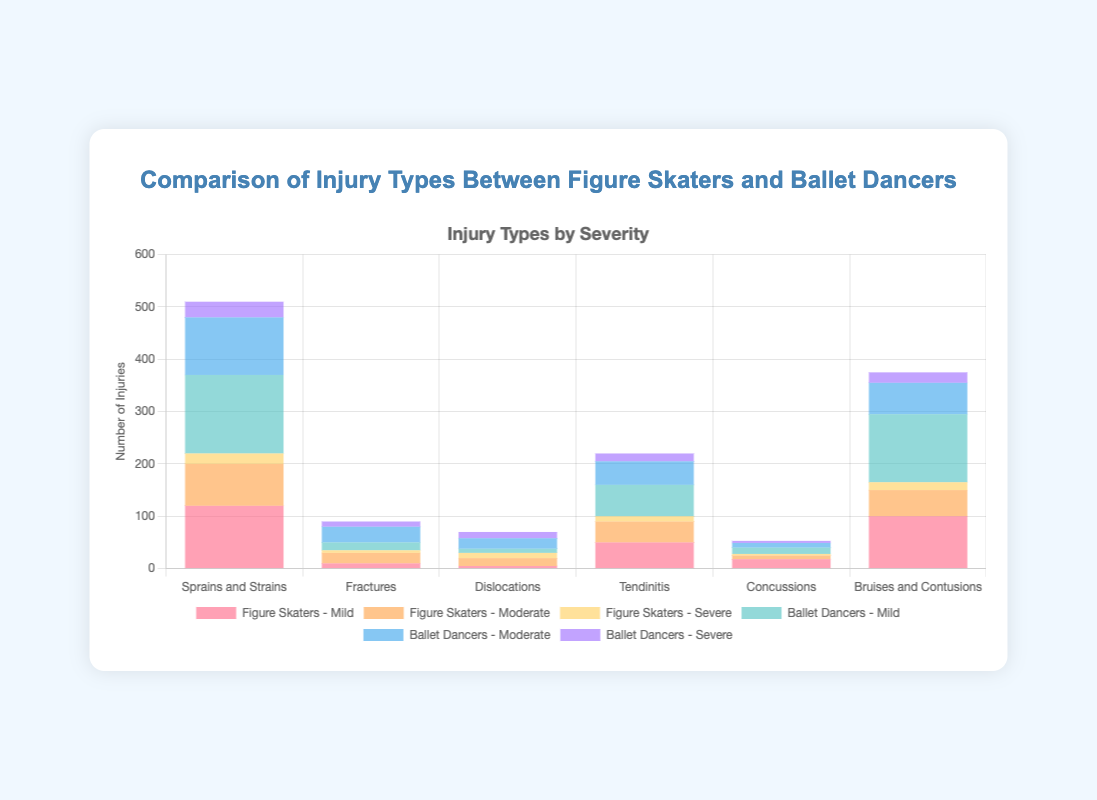Which group has the highest number of severe injuries for Sprains and Strains? To find the group with the highest number of severe injuries for Sprains and Strains, compare the severe counts between figure skaters and ballet dancers. Figure skaters have 20 severe injuries, while ballet dancers have 30. Therefore, ballet dancers have the highest number.
Answer: Ballet dancers In the category of Fractures, what is the total number of injuries that figure skaters experience? Add up the mild, moderate, and severe injuries for figure skaters in the Fractures category. The numbers are 10 (mild) + 20 (moderate) + 5 (severe), totaling 35 injuries.
Answer: 35 Which injury type has the highest number of moderate injuries for ballet dancers? To find the injury type with the highest number of moderate injuries for ballet dancers, compare moderate injury numbers for each type. The values are 110 (Sprains and Strains), 30 (Fractures), 20 (Dislocations), 45 (Tendinitis), 9 (Concussions), and 60 (Bruises and Contusions). The highest number is 110 for Sprains and Strains.
Answer: Sprains and Strains What is the ratio of mild to severe injuries for figure skaters in the Tendinitis category? Calculate the ratio by dividing the number of mild injuries by the number of severe injuries for figure skaters in the Tendinitis category. The values are 50 (mild) and 10 (severe), so the ratio is 50/10 = 5.
Answer: 5 How many more moderate injuries do figure skaters have compared to ballet dancers in the Fractures category? Subtract the number of moderate Fractures for ballet dancers from the number for figure skaters. Figure skaters have 20, and ballet dancers have 30, so the difference is 30 - 20 = 10.
Answer: 10 What color represents the severe injuries for ballet dancers? By observing the legend in the chart, you can see that severe injuries for ballet dancers are represented by the color purple.
Answer: Purple For which injury type do figure skaters have the lowest total number of injuries? Calculate the total number of injuries for figure skaters in each injury type by summing the mild, moderate, and severe counts for each type, and then compare them. The totals are 220 (Sprains and Strains), 35 (Fractures), 30 (Dislocations), 100 (Tendinitis), 28 (Concussions), and 165 (Bruises and Contusions). The lowest total is 28 for Concussions.
Answer: Concussions 